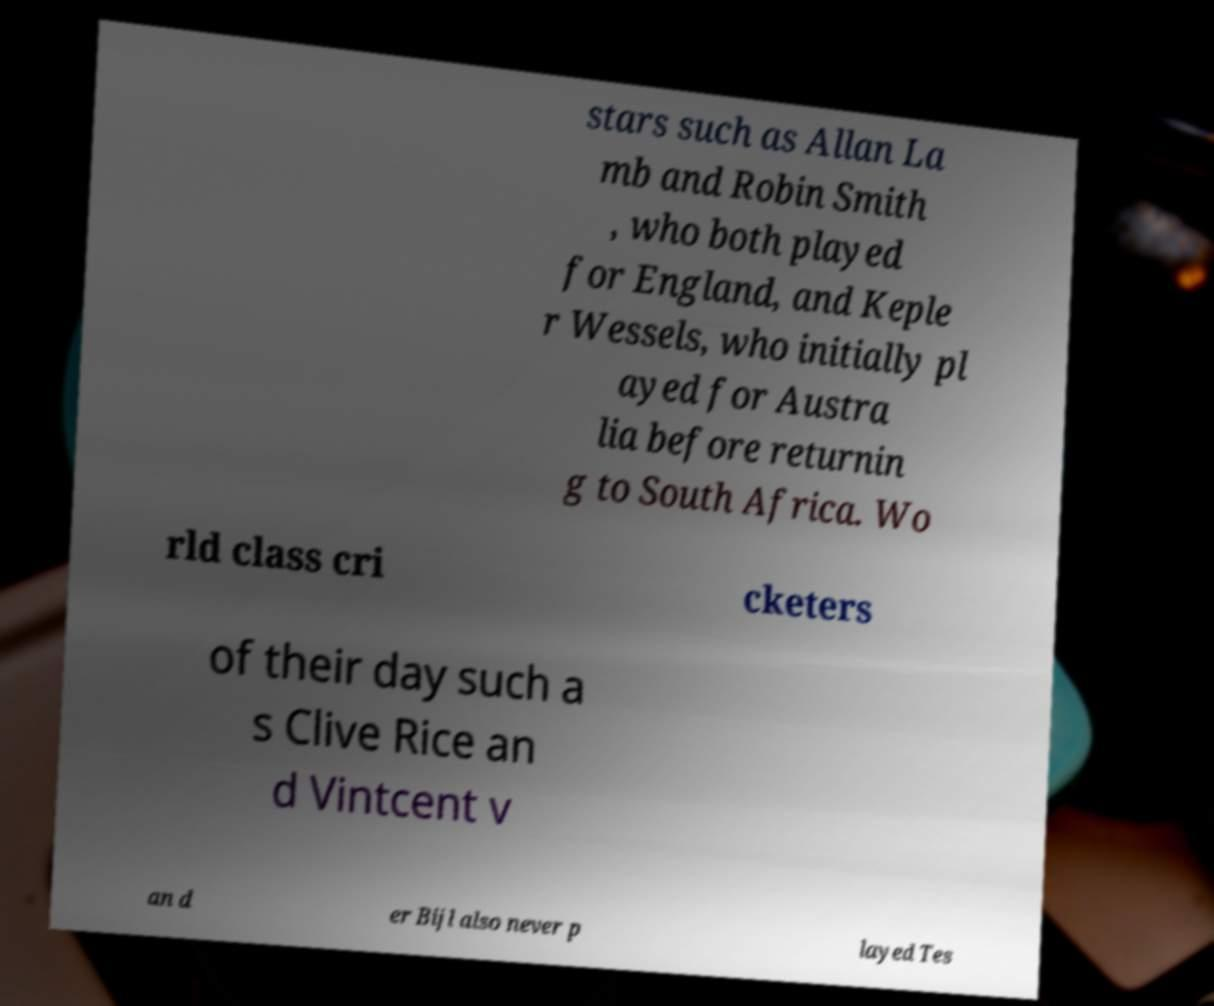What messages or text are displayed in this image? I need them in a readable, typed format. stars such as Allan La mb and Robin Smith , who both played for England, and Keple r Wessels, who initially pl ayed for Austra lia before returnin g to South Africa. Wo rld class cri cketers of their day such a s Clive Rice an d Vintcent v an d er Bijl also never p layed Tes 